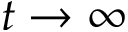Convert formula to latex. <formula><loc_0><loc_0><loc_500><loc_500>t \rightarrow \infty</formula> 